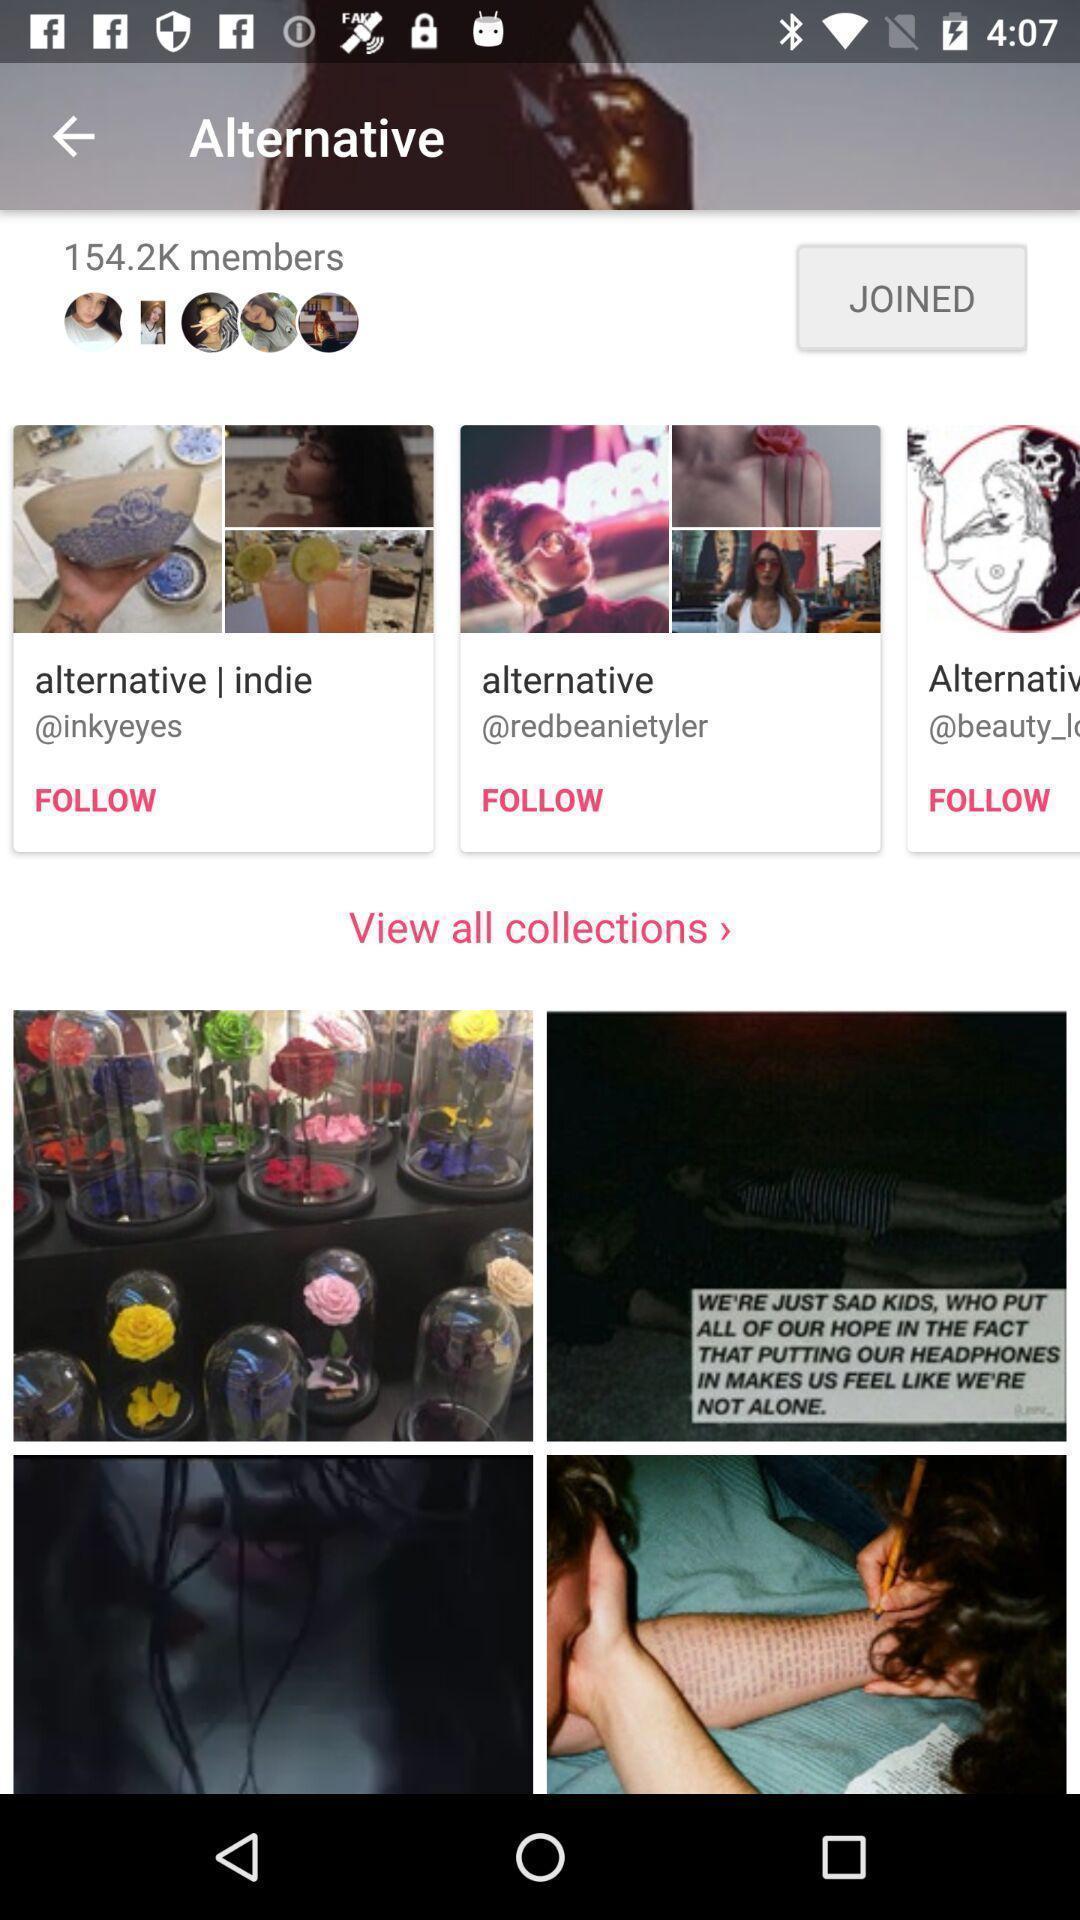Tell me what you see in this picture. Page showing a group on a social media app. 